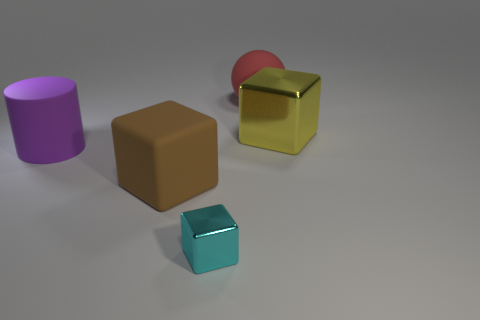Add 5 yellow blocks. How many objects exist? 10 Subtract all cylinders. How many objects are left? 4 Add 5 purple rubber cylinders. How many purple rubber cylinders exist? 6 Subtract 0 red cylinders. How many objects are left? 5 Subtract all matte cubes. Subtract all big metallic objects. How many objects are left? 3 Add 3 big red spheres. How many big red spheres are left? 4 